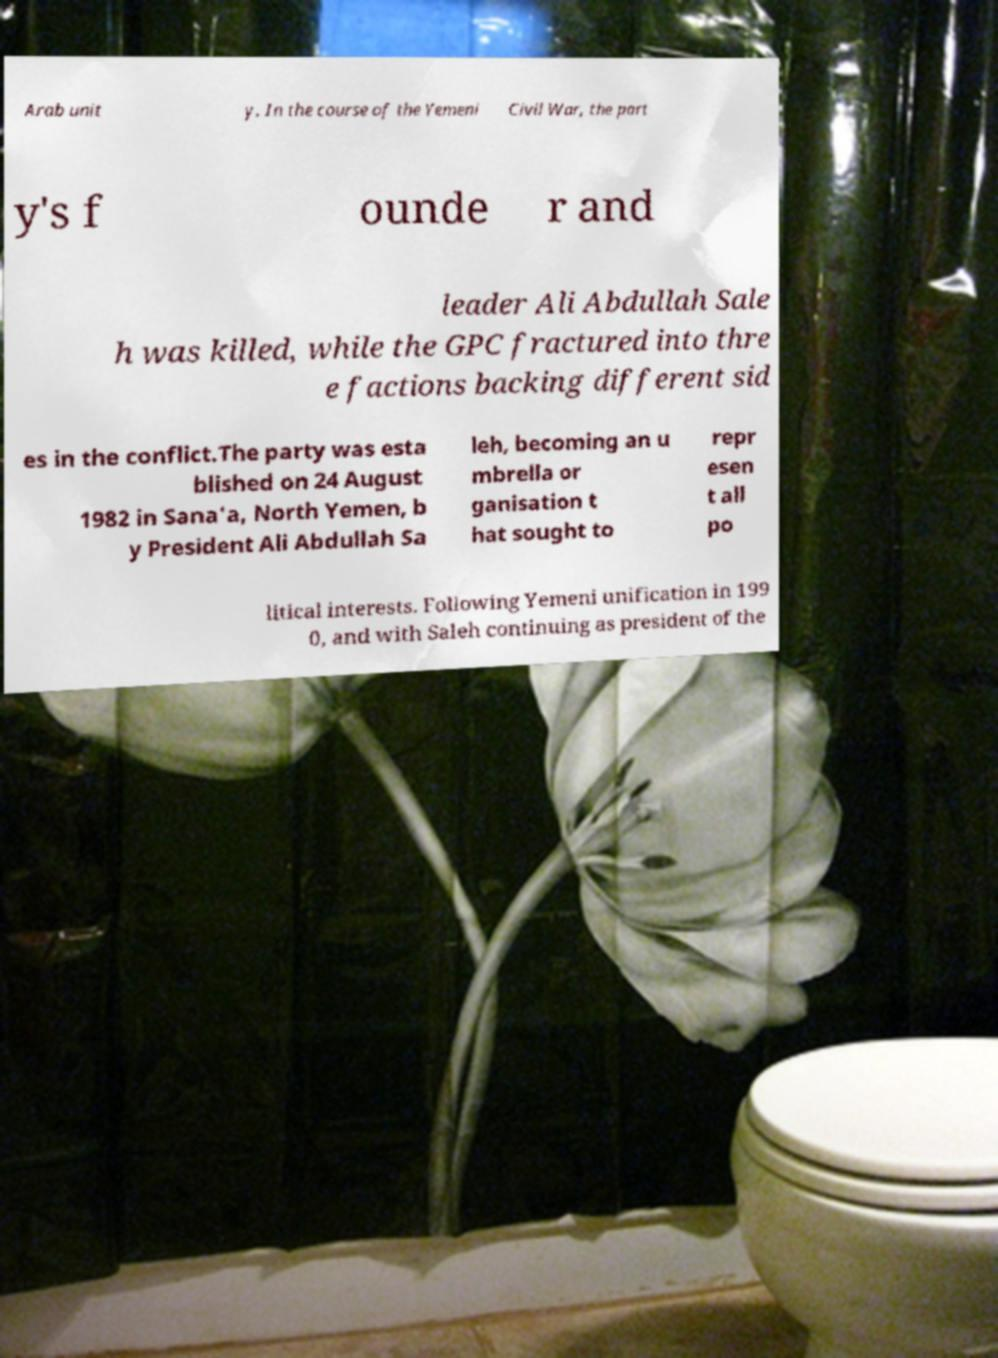What messages or text are displayed in this image? I need them in a readable, typed format. Arab unit y. In the course of the Yemeni Civil War, the part y's f ounde r and leader Ali Abdullah Sale h was killed, while the GPC fractured into thre e factions backing different sid es in the conflict.The party was esta blished on 24 August 1982 in Sana'a, North Yemen, b y President Ali Abdullah Sa leh, becoming an u mbrella or ganisation t hat sought to repr esen t all po litical interests. Following Yemeni unification in 199 0, and with Saleh continuing as president of the 